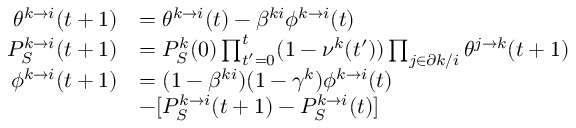Convert formula to latex. <formula><loc_0><loc_0><loc_500><loc_500>\begin{array} { r l } { \theta ^ { k \to i } ( t + 1 ) } & { = \theta ^ { k \to i } ( t ) - \beta ^ { k i } \phi ^ { k \to i } ( t ) } \\ { P _ { S } ^ { k \to i } ( t + 1 ) } & { = P _ { S } ^ { k } ( 0 ) \prod _ { t ^ { \prime } = 0 } ^ { t } ( 1 - \nu ^ { k } ( t ^ { \prime } ) ) \prod _ { j \in \partial k / i } \theta ^ { j \to k } ( t + 1 ) } \\ { \phi ^ { k \to i } ( t + 1 ) } & { = ( 1 - \beta ^ { k i } ) ( 1 - \gamma ^ { k } ) \phi ^ { k \to i } ( t ) } \\ & { - [ P _ { S } ^ { k \to i } ( t + 1 ) - P _ { S } ^ { k \to i } ( t ) ] } \end{array}</formula> 